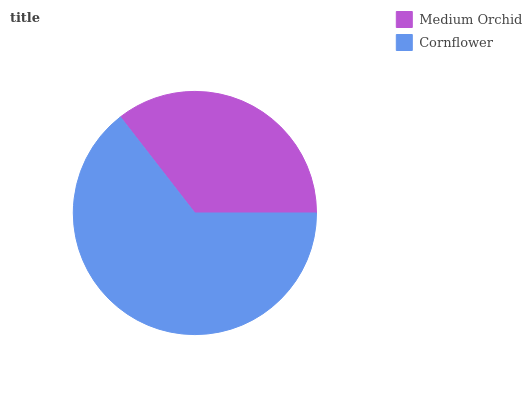Is Medium Orchid the minimum?
Answer yes or no. Yes. Is Cornflower the maximum?
Answer yes or no. Yes. Is Cornflower the minimum?
Answer yes or no. No. Is Cornflower greater than Medium Orchid?
Answer yes or no. Yes. Is Medium Orchid less than Cornflower?
Answer yes or no. Yes. Is Medium Orchid greater than Cornflower?
Answer yes or no. No. Is Cornflower less than Medium Orchid?
Answer yes or no. No. Is Cornflower the high median?
Answer yes or no. Yes. Is Medium Orchid the low median?
Answer yes or no. Yes. Is Medium Orchid the high median?
Answer yes or no. No. Is Cornflower the low median?
Answer yes or no. No. 